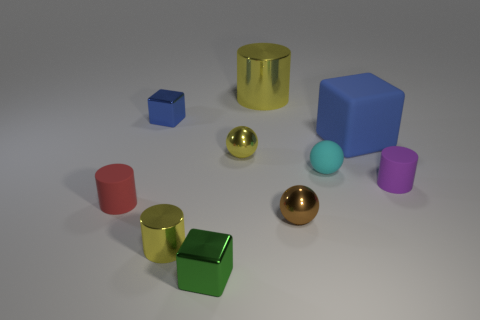What is the material of the blue block that is to the left of the small yellow metal object behind the brown ball?
Provide a succinct answer. Metal. Are there fewer red objects that are behind the purple cylinder than cylinders that are in front of the large yellow metallic thing?
Your response must be concise. Yes. How many yellow objects are big metal objects or metallic things?
Your answer should be very brief. 3. Is the number of tiny red objects right of the small yellow metallic cylinder the same as the number of small green shiny things?
Provide a short and direct response. No. How many objects are either tiny green blocks or tiny yellow metallic objects that are in front of the small purple thing?
Ensure brevity in your answer.  2. Is the color of the large metal object the same as the small metallic cylinder?
Your answer should be very brief. Yes. Is there a big yellow object that has the same material as the tiny green cube?
Ensure brevity in your answer.  Yes. What is the color of the big object that is the same shape as the small purple rubber thing?
Offer a terse response. Yellow. Do the red cylinder and the cyan thing behind the small purple cylinder have the same material?
Offer a terse response. Yes. What shape is the yellow thing that is left of the small metal cube in front of the matte cube?
Offer a very short reply. Cylinder. 